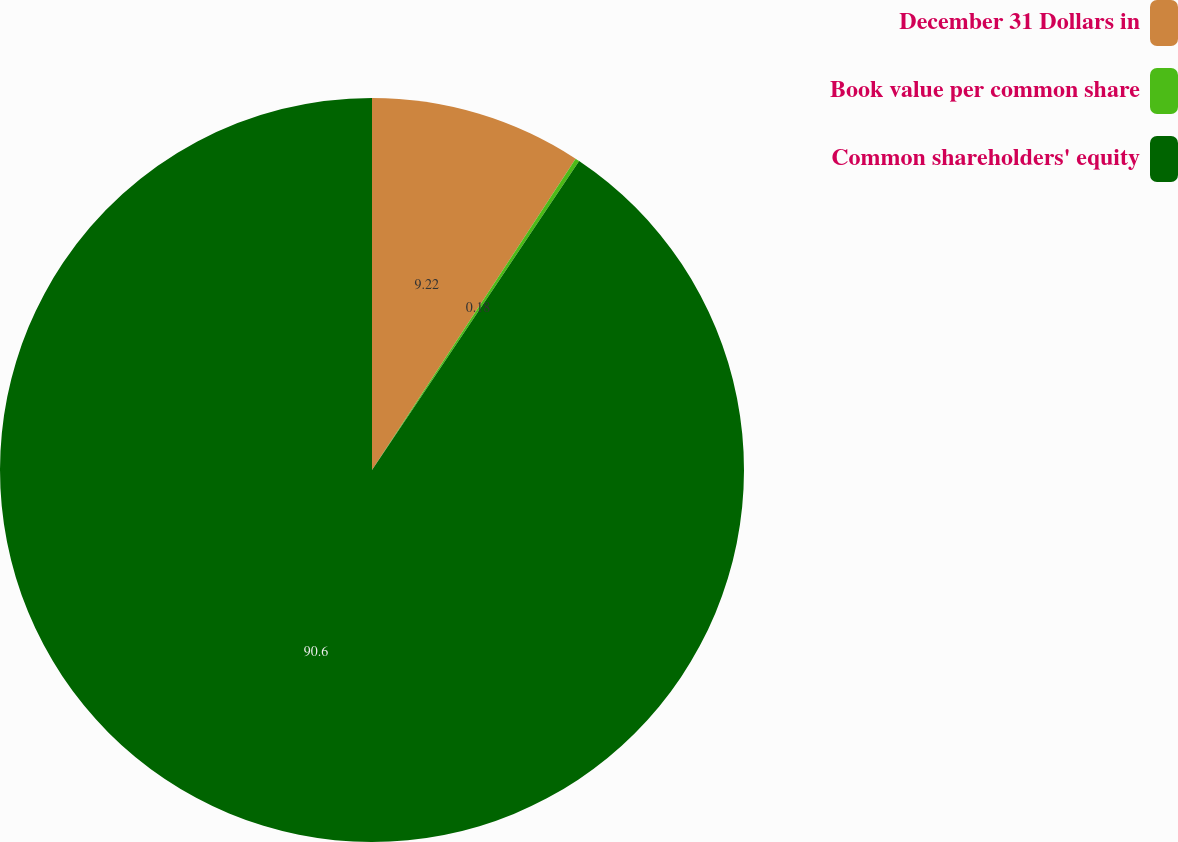<chart> <loc_0><loc_0><loc_500><loc_500><pie_chart><fcel>December 31 Dollars in<fcel>Book value per common share<fcel>Common shareholders' equity<nl><fcel>9.22%<fcel>0.18%<fcel>90.6%<nl></chart> 